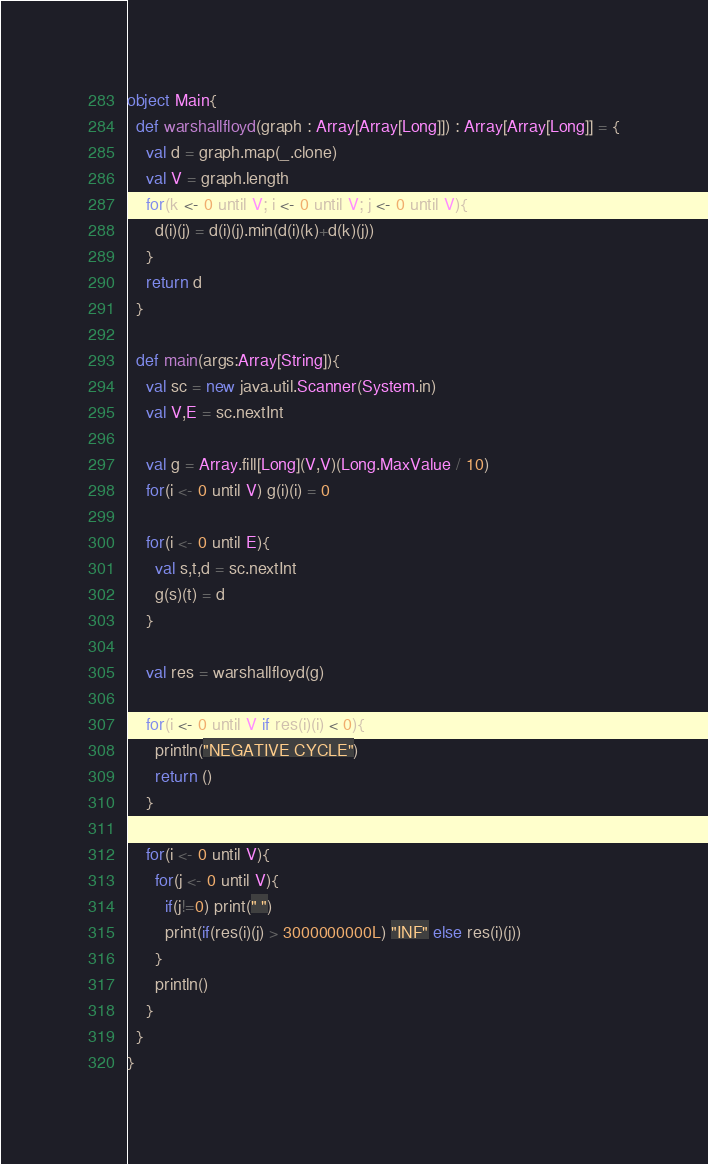<code> <loc_0><loc_0><loc_500><loc_500><_Scala_>object Main{
  def warshallfloyd(graph : Array[Array[Long]]) : Array[Array[Long]] = {
    val d = graph.map(_.clone)
    val V = graph.length
    for(k <- 0 until V; i <- 0 until V; j <- 0 until V){
      d(i)(j) = d(i)(j).min(d(i)(k)+d(k)(j))
    }
    return d
  }

  def main(args:Array[String]){
    val sc = new java.util.Scanner(System.in)
    val V,E = sc.nextInt

    val g = Array.fill[Long](V,V)(Long.MaxValue / 10)
    for(i <- 0 until V) g(i)(i) = 0

    for(i <- 0 until E){
      val s,t,d = sc.nextInt
      g(s)(t) = d
    }

    val res = warshallfloyd(g)

    for(i <- 0 until V if res(i)(i) < 0){
      println("NEGATIVE CYCLE")
      return ()
    }

    for(i <- 0 until V){
      for(j <- 0 until V){
        if(j!=0) print(" ")
        print(if(res(i)(j) > 3000000000L) "INF" else res(i)(j))
      }
      println()
    }
  }
}</code> 